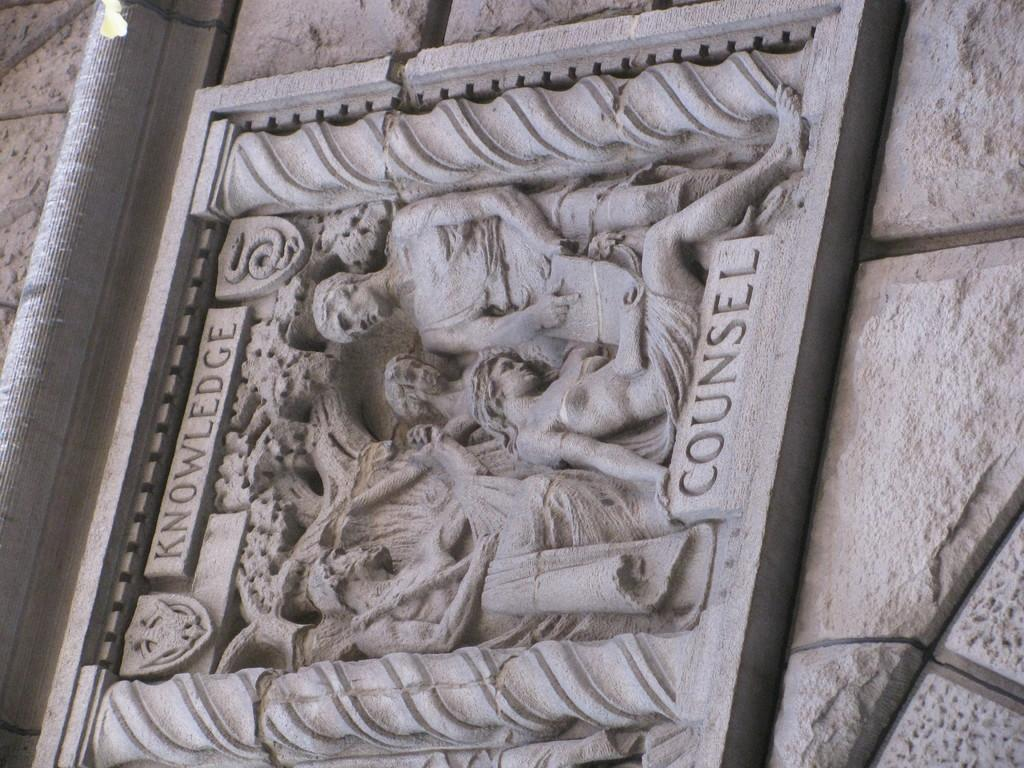What is present on the wall in the image? There are sculptures on the wall in the image. Can you describe the sculptures? Unfortunately, the provided facts do not give enough information to describe the sculptures. What else can be seen in the image besides the wall and sculptures? There are two words visible in the image. What is the brain doing during the journey in the image? There is no brain or journey depicted in the image; it only features a wall with sculptures and two visible words. 